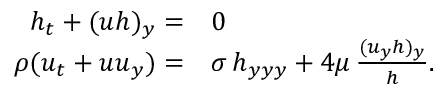<formula> <loc_0><loc_0><loc_500><loc_500>\begin{array} { r l } { h _ { t } + ( u h ) _ { y } = } & 0 } \\ { \rho ( u _ { t } + u u _ { y } ) = } & \sigma \, h _ { y y y } + 4 \mu \, \frac { ( u _ { y } h ) _ { y } } { h } . } \end{array}</formula> 